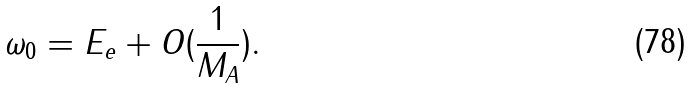<formula> <loc_0><loc_0><loc_500><loc_500>\omega _ { 0 } = E _ { e } + O ( \frac { 1 } { M _ { A } } ) .</formula> 